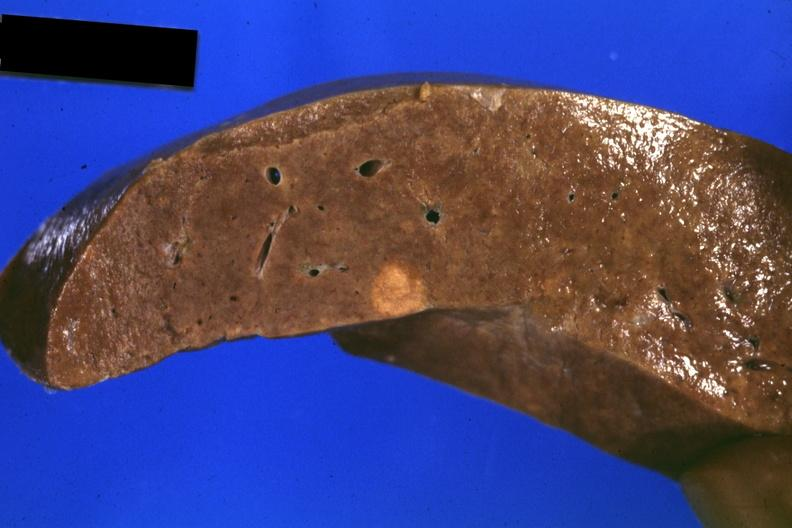what is present?
Answer the question using a single word or phrase. Hepatobiliary 